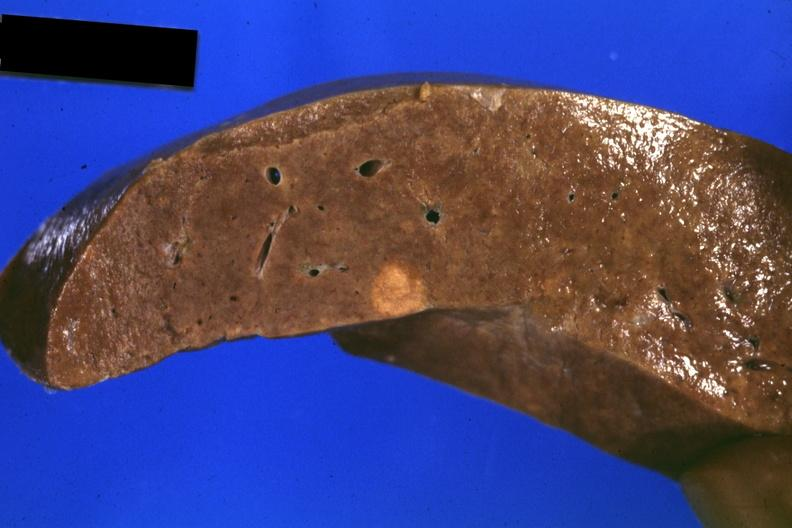what is present?
Answer the question using a single word or phrase. Hepatobiliary 